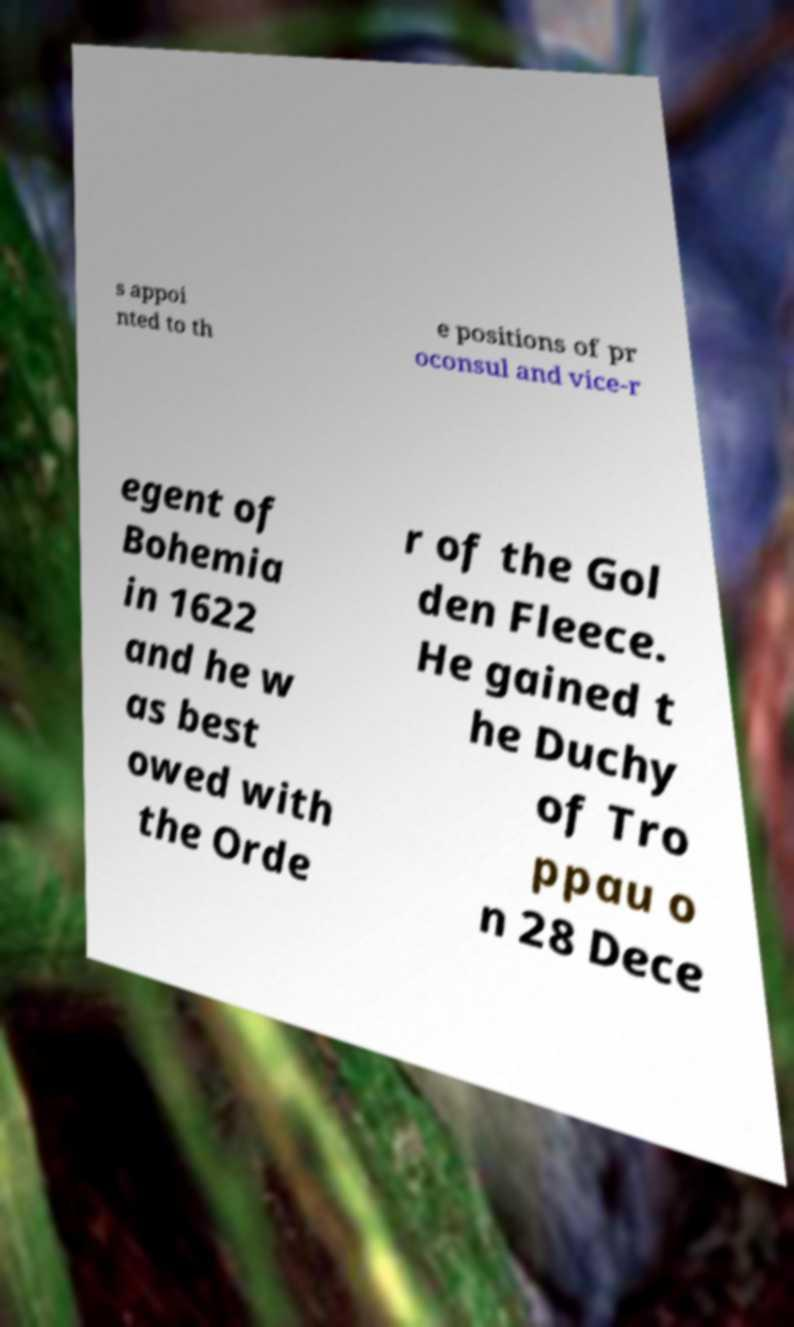Could you assist in decoding the text presented in this image and type it out clearly? s appoi nted to th e positions of pr oconsul and vice-r egent of Bohemia in 1622 and he w as best owed with the Orde r of the Gol den Fleece. He gained t he Duchy of Tro ppau o n 28 Dece 